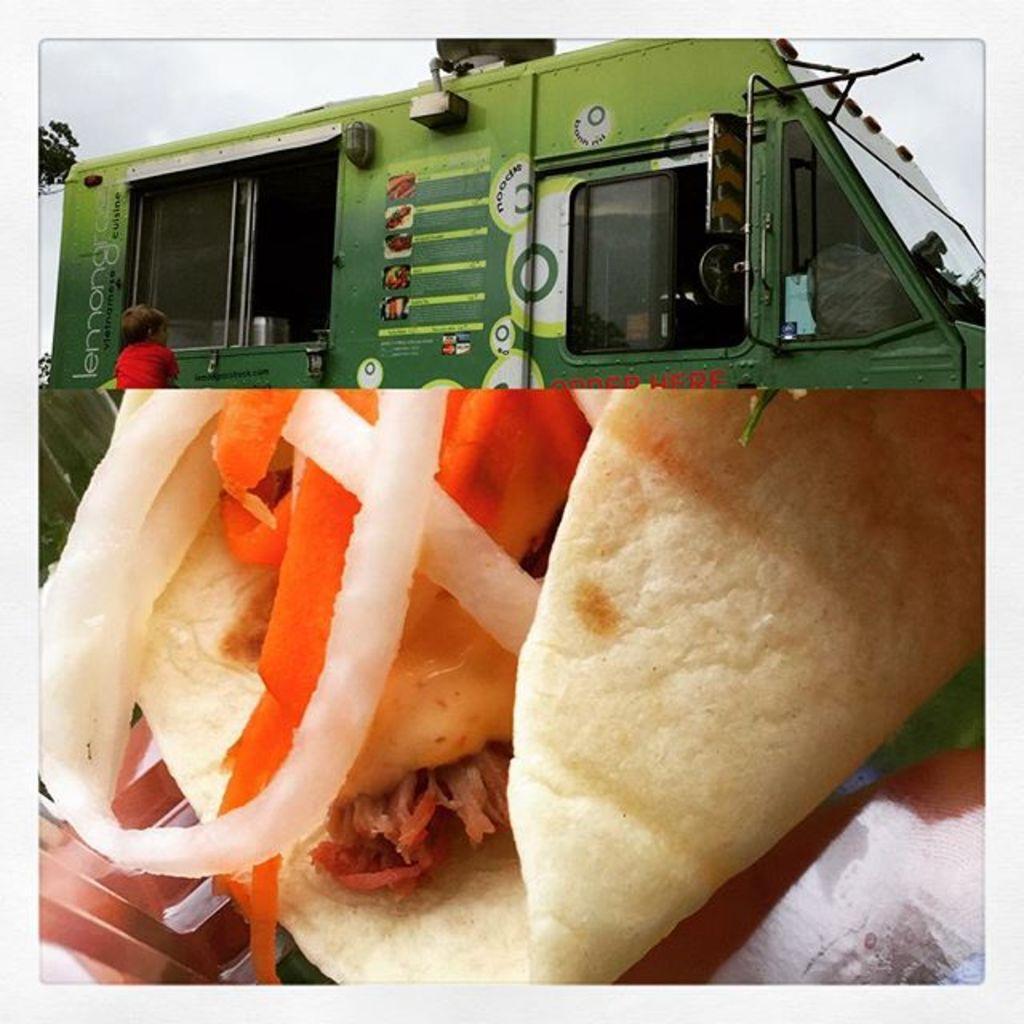Please provide a concise description of this image. This image is a collage of two images. At the bottom of the image there is a food item. At the top of the image there is a truck and there is a kid. 